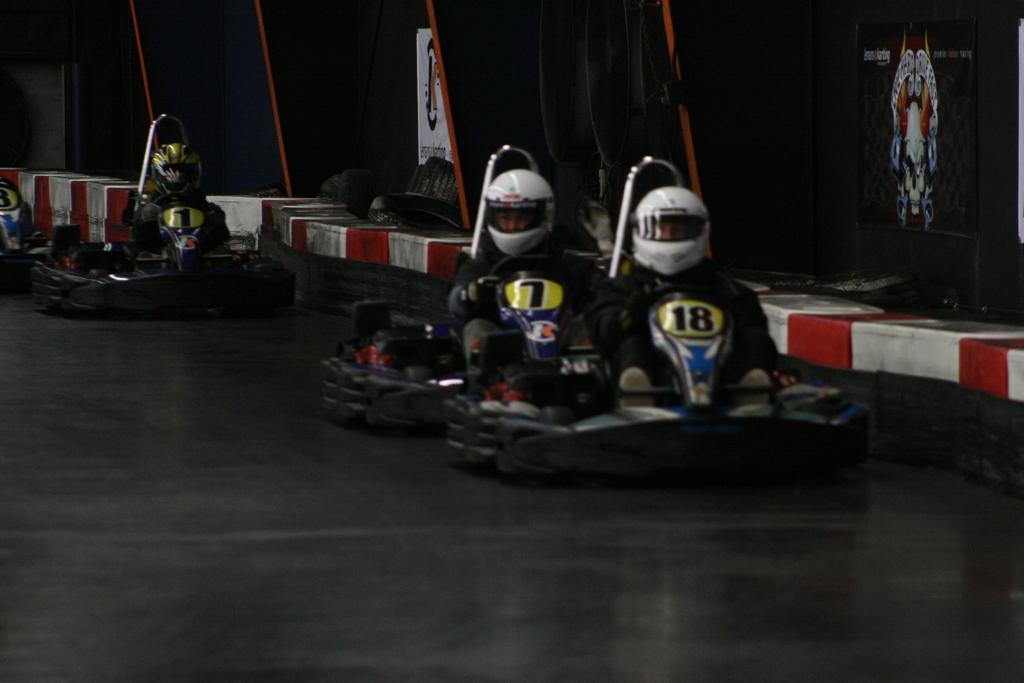Who is present in the image? There are people in the image. What are the people wearing on their heads? The people are wearing helmets. What are the people sitting on in the image? The people are sitting on vehicles. Where are the vehicles located in the image? The vehicles are on the floor. What else can be seen in the image besides the people and vehicles? There are objects visible in the image. What type of food is being cracked open by the person in the image? There is no person or food present in the image; it features people wearing helmets and sitting on vehicles. 